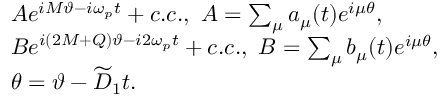<formula> <loc_0><loc_0><loc_500><loc_500>\begin{array} { r l } & { A e ^ { i M \vartheta - i \omega _ { p } t } + c . c . , A = \sum _ { \mu } a _ { \mu } ( t ) e ^ { i \mu \theta } , } \\ & { B e ^ { i ( 2 M + Q ) \vartheta - i 2 \omega _ { p } t } + c . c . , B = \sum _ { \mu } b _ { \mu } ( t ) e ^ { i \mu \theta } , } \\ & { \theta = \vartheta - \widetilde { D } _ { 1 } t . } \end{array}</formula> 